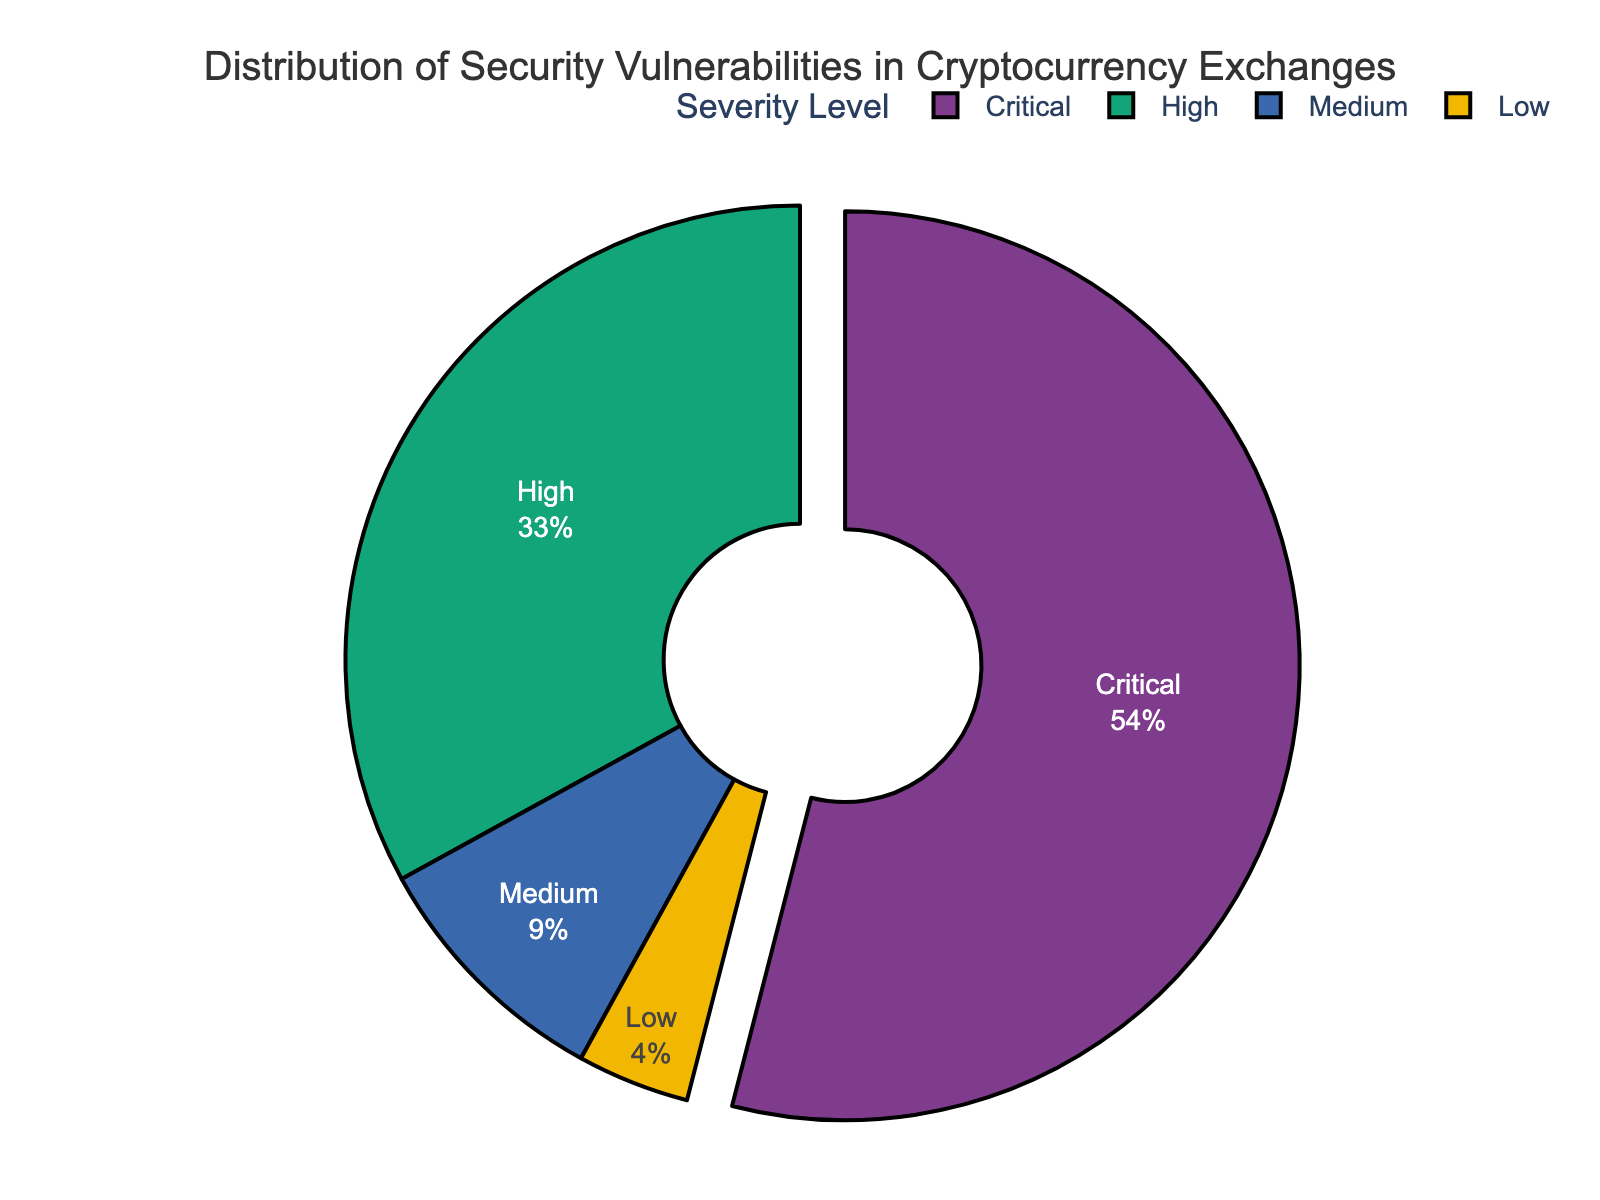What percentage of the security vulnerabilities are classified as Critical? By looking at the pie chart, the segment labeled "Critical" represents the percentage of vulnerabilities classified as Critical.
Answer: 54% Compare the proportion of High severity vulnerabilities to Low severity vulnerabilities. Which is greater and by how much? The pie chart shows visual segments for High and Low severity vulnerabilities. The High severity segment is larger at 33%, and the Low severity segment is smaller at 4%. The difference is 33% - 4% = 29%.
Answer: High by 29% What is the combined percentage of Medium and Low severity vulnerabilities? The segment labeled "Medium" represents 9%, and the segment labeled "Low" represents 4% in the pie chart. Adding these together gives 9% + 4% = 13%.
Answer: 13% Which severity level has the smallest proportion of vulnerabilities and what is that proportion? Observing the chart, the smallest segment is labeled "Low" and represents 4% of the vulnerabilities.
Answer: Low, 4% Is the total percentage of High and Critical severity vulnerabilities greater than 50%? By examining the pie chart, we see that the High severity is 33% and Critical is 54%. Adding these two gives 33% + 54% = 87%, which is greater than 50%.
Answer: Yes, 87% What's the ratio of Critical severity vulnerabilities to Medium severity vulnerabilities? From the chart, the Critical severity vulnerabilities are 54% and the Medium are 9%. The ratio is 54% / 9% = 6.
Answer: 6:1 By how many percentage points does the Critical severity surpass the next highest severity? The Critical severity is 54%, and the next highest is High severity at 33%. The difference is 54% - 33% = 21 percentage points.
Answer: 21 percentage points What percentage of the vulnerabilities fall under the High or Medium categories? The High severity is 33% and the Medium severity is 9%. Adding these gives us 33% + 9% = 42%.
Answer: 42% 